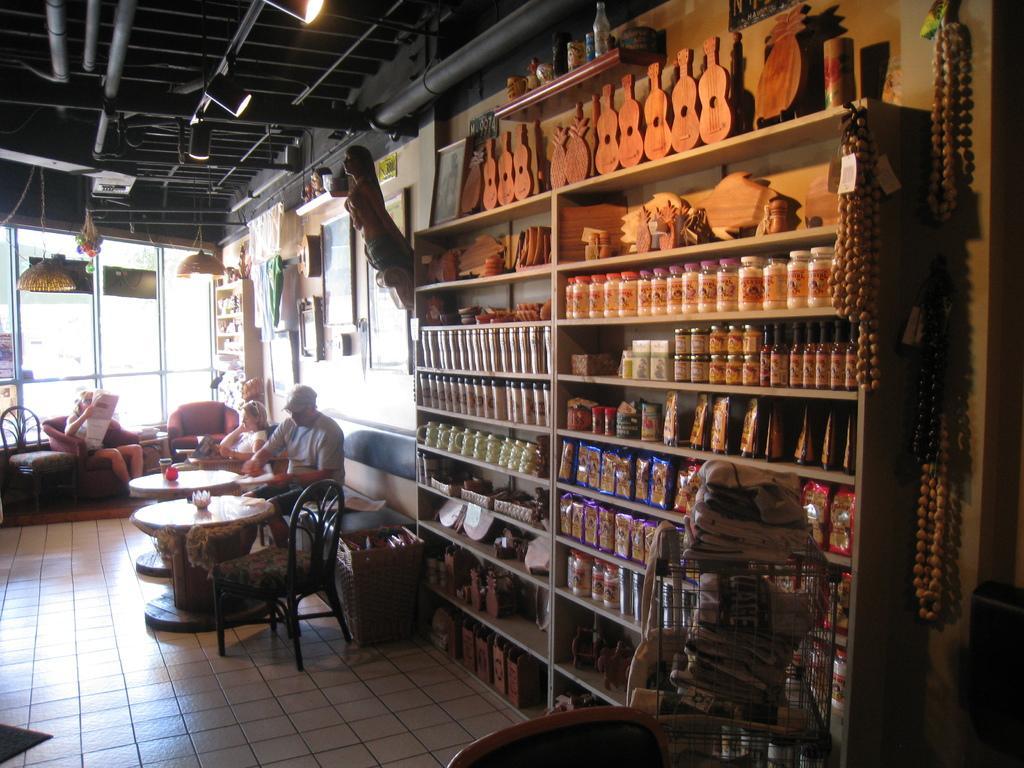Could you give a brief overview of what you see in this image? In this image, we can see a big shelf , few are are filled on it. On left side, few peoples are sat on the chair and bench. We can see tables ,few items are placed on it, chair there is a back side, In the middle and the floor at the bottom. There is a roof in black color and lights. 